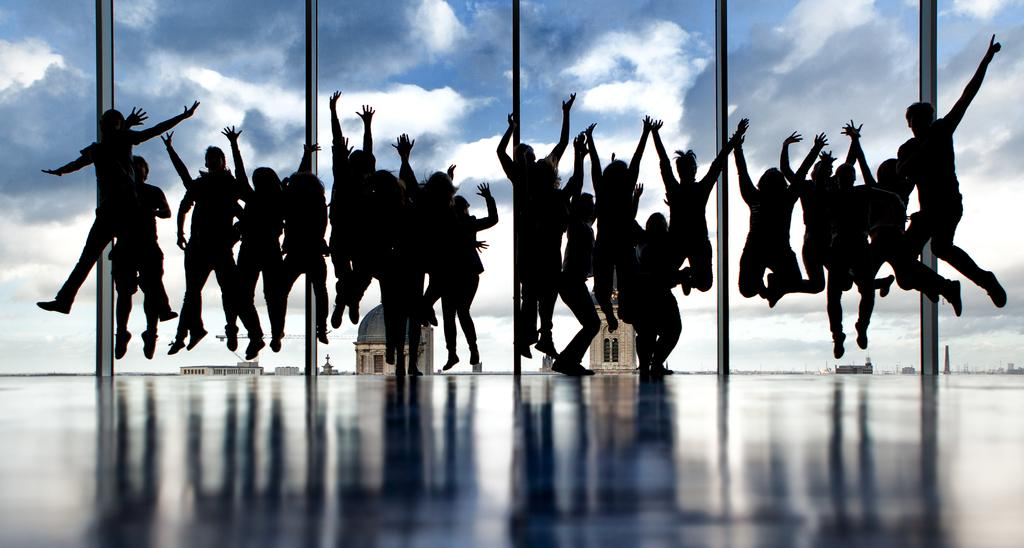Who is present in the image? There are people in the image. What are the people doing in the image? The people are jumping on the floor. What can be seen in the background of the image? There is sky visible in the image. What is the condition of the sky in the image? There are clouds in the sky. What type of soup is being served to the sister in the image? There is no sister or soup present in the image. How many grains of rice can be seen on the floor during the jumping activity? There is no reference to rice or grains in the image, so it is not possible to determine the number of grains on the floor. 